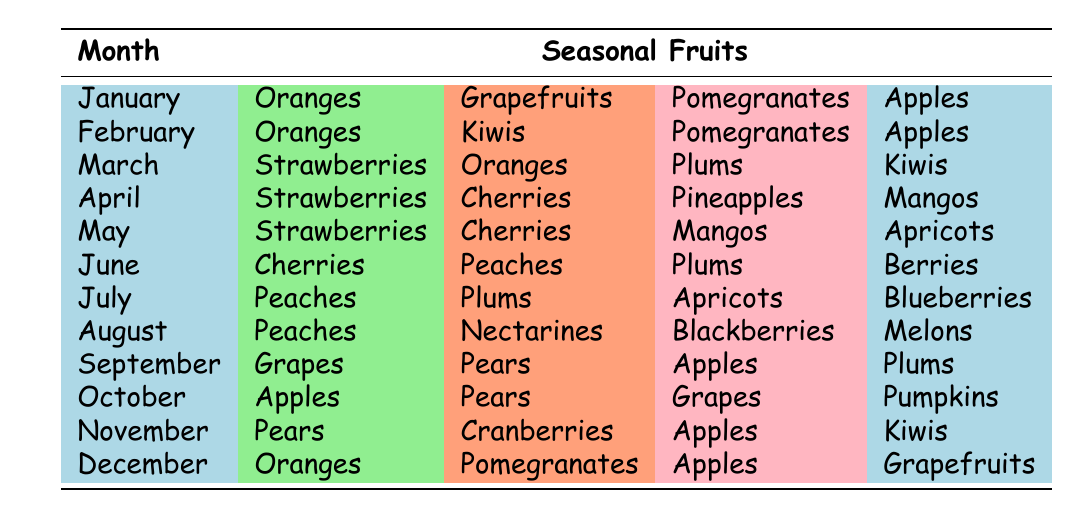What fruits are available in December? Referring to the table, the fruits listed for December are Oranges, Pomegranates, Apples, and Grapefruits.
Answer: Oranges, Pomegranates, Apples, Grapefruits How many types of fruits are available in June? In June, the table lists Cherries, Peaches, Plums, and Berries, which means there are four types of fruits available.
Answer: Four Are strawberries available in the month of August? The table shows that strawberries are not listed for August, therefore, the answer is no.
Answer: No What is the only fruit available in both October and November? Looking at both months, Apples are listed in October and also in November, making them the only common fruit.
Answer: Apples How many different fruits can you find in January and February combined? In January, there are four fruits: Oranges, Grapefruits, Pomegranates, and Apples. In February, the fruits are Oranges, Kiwis, Pomegranates, and Apples. The total unique fruits for both months are Oranges, Grapefruits, Pomegranates, Apples, and Kiwis, which sums up to five unique fruits.
Answer: Five Is there a month that has Mangos as an available fruit? Checking the table, Mangos are listed for April and May, so the answer is yes.
Answer: Yes Which month has the most varied selection of fruits between the three months of June, July, and August? In June (4 types), July (4 types), and August (4 types), all months have an equal count of fruits. However, focusing on variety, August includes Peaches, Nectarines, Blackberries, and Melons which are not available in the previous two months. Therefore, August has the most variety.
Answer: August Are there any months without grapes available? The months where grapes are not listed are January, February, March, May, June, July, August, September, and December, which means there are multiple months without grapes.
Answer: Yes How many fruits are listed for the month of March? In March, the fruits listed are Strawberries, Oranges, Plums, and Kiwis, which makes a total of four types of fruits.
Answer: Four 